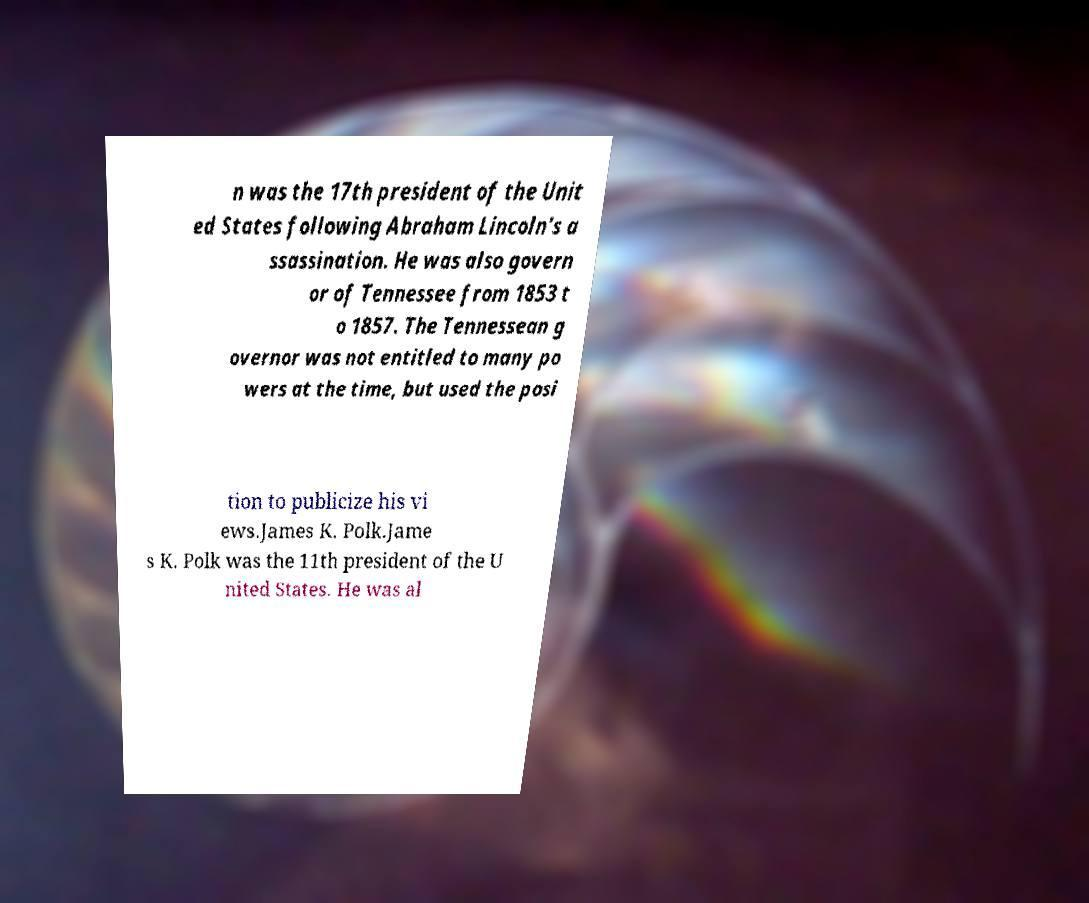There's text embedded in this image that I need extracted. Can you transcribe it verbatim? n was the 17th president of the Unit ed States following Abraham Lincoln's a ssassination. He was also govern or of Tennessee from 1853 t o 1857. The Tennessean g overnor was not entitled to many po wers at the time, but used the posi tion to publicize his vi ews.James K. Polk.Jame s K. Polk was the 11th president of the U nited States. He was al 